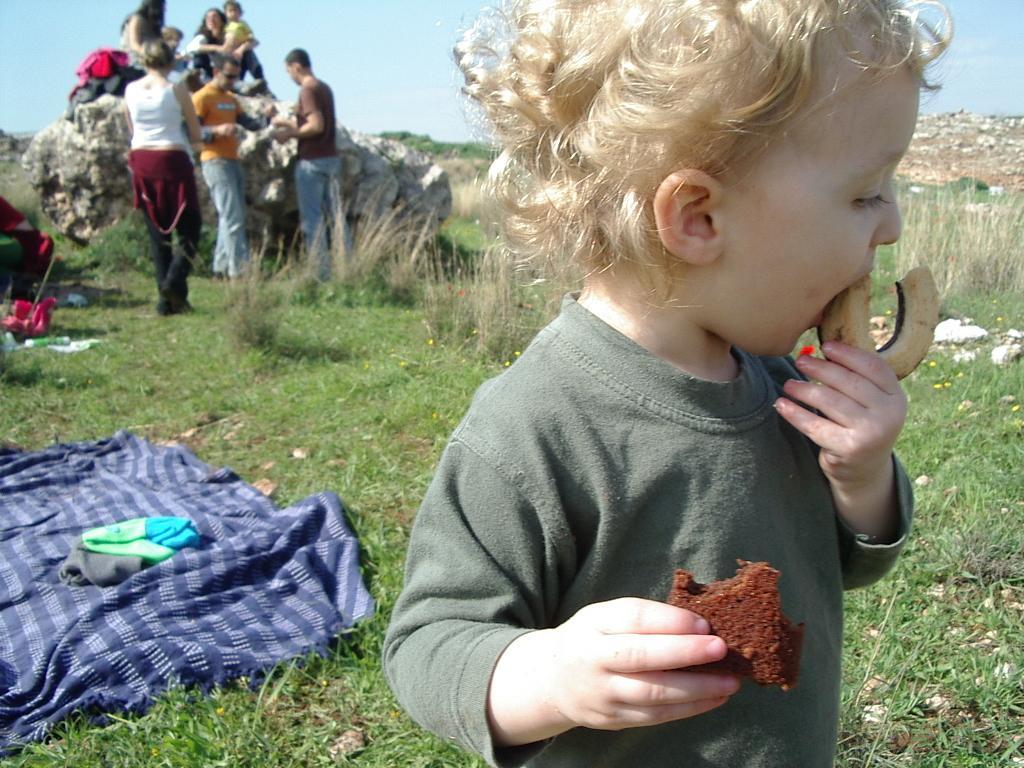Please provide a concise description of this image. This picture shows few people standing and few are seated on the rock and we see a kid holding a donut in one hand and a cake in other hand and we see cloth blanket and bag on it and we see grass on the ground and we see a cloudy Sky. 